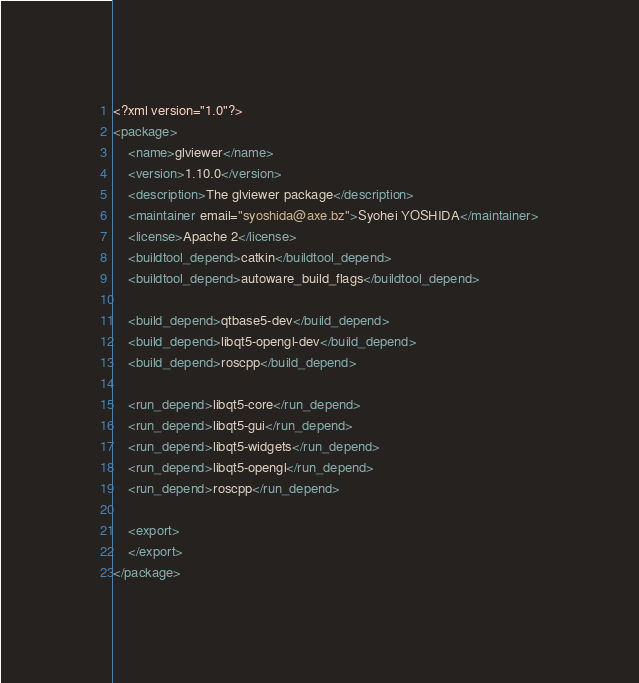<code> <loc_0><loc_0><loc_500><loc_500><_XML_><?xml version="1.0"?>
<package>
    <name>glviewer</name>
    <version>1.10.0</version>
    <description>The glviewer package</description>
    <maintainer email="syoshida@axe.bz">Syohei YOSHIDA</maintainer>
    <license>Apache 2</license>
    <buildtool_depend>catkin</buildtool_depend>
    <buildtool_depend>autoware_build_flags</buildtool_depend>

    <build_depend>qtbase5-dev</build_depend>
    <build_depend>libqt5-opengl-dev</build_depend>
    <build_depend>roscpp</build_depend>

    <run_depend>libqt5-core</run_depend>
    <run_depend>libqt5-gui</run_depend>
    <run_depend>libqt5-widgets</run_depend>
    <run_depend>libqt5-opengl</run_depend>
    <run_depend>roscpp</run_depend>

    <export>
    </export>
</package>
</code> 